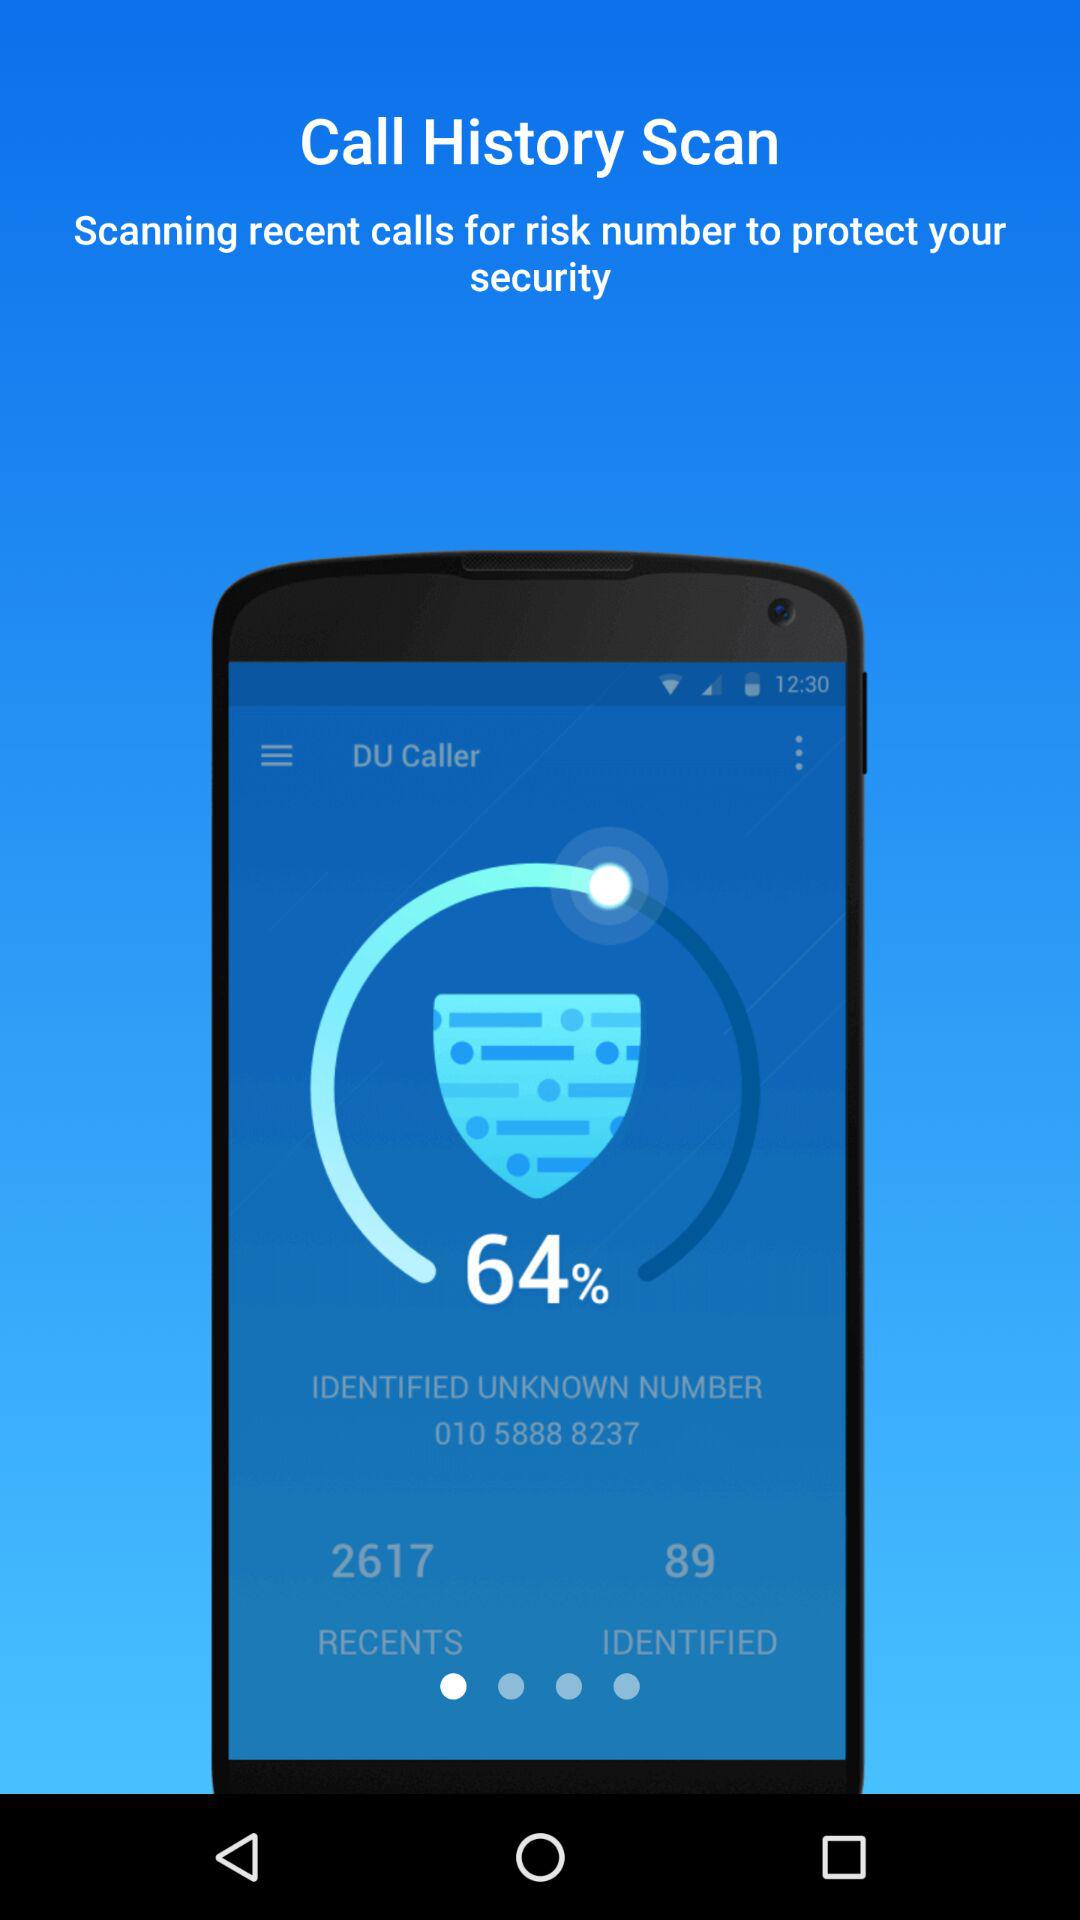How many recent calls are identified?
Answer the question using a single word or phrase. 89 